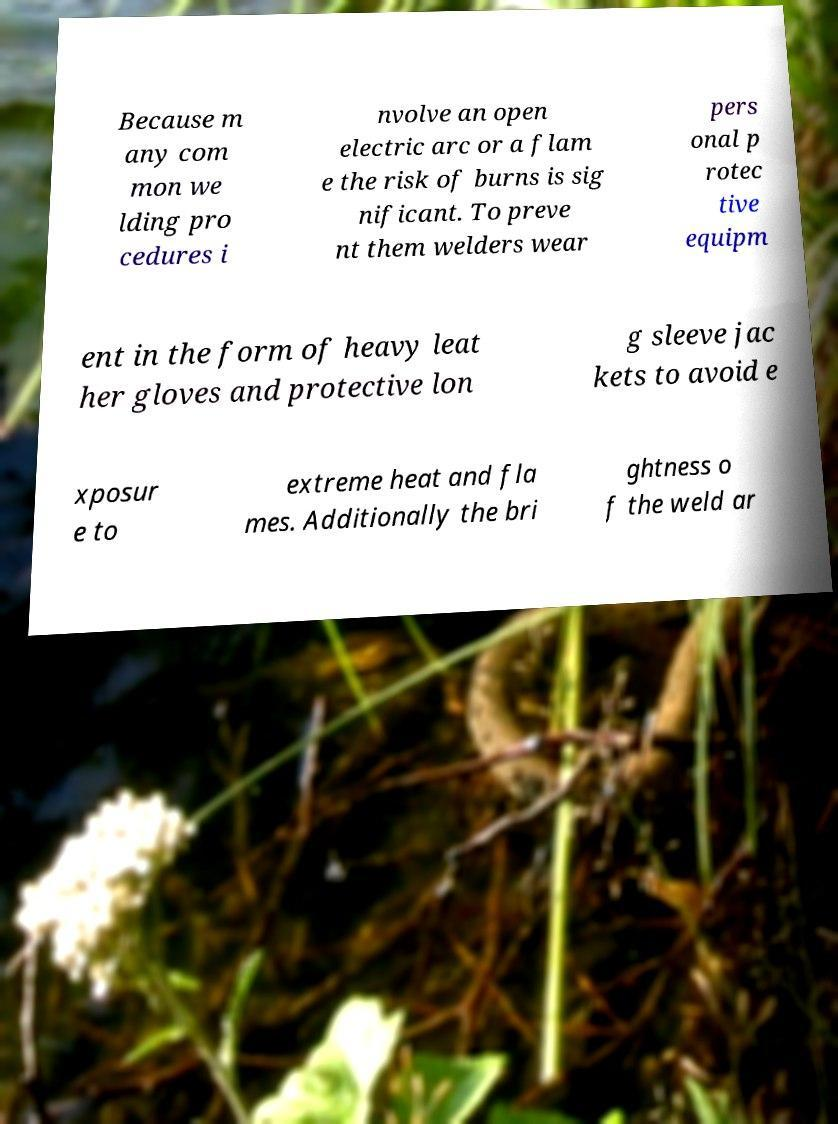There's text embedded in this image that I need extracted. Can you transcribe it verbatim? Because m any com mon we lding pro cedures i nvolve an open electric arc or a flam e the risk of burns is sig nificant. To preve nt them welders wear pers onal p rotec tive equipm ent in the form of heavy leat her gloves and protective lon g sleeve jac kets to avoid e xposur e to extreme heat and fla mes. Additionally the bri ghtness o f the weld ar 